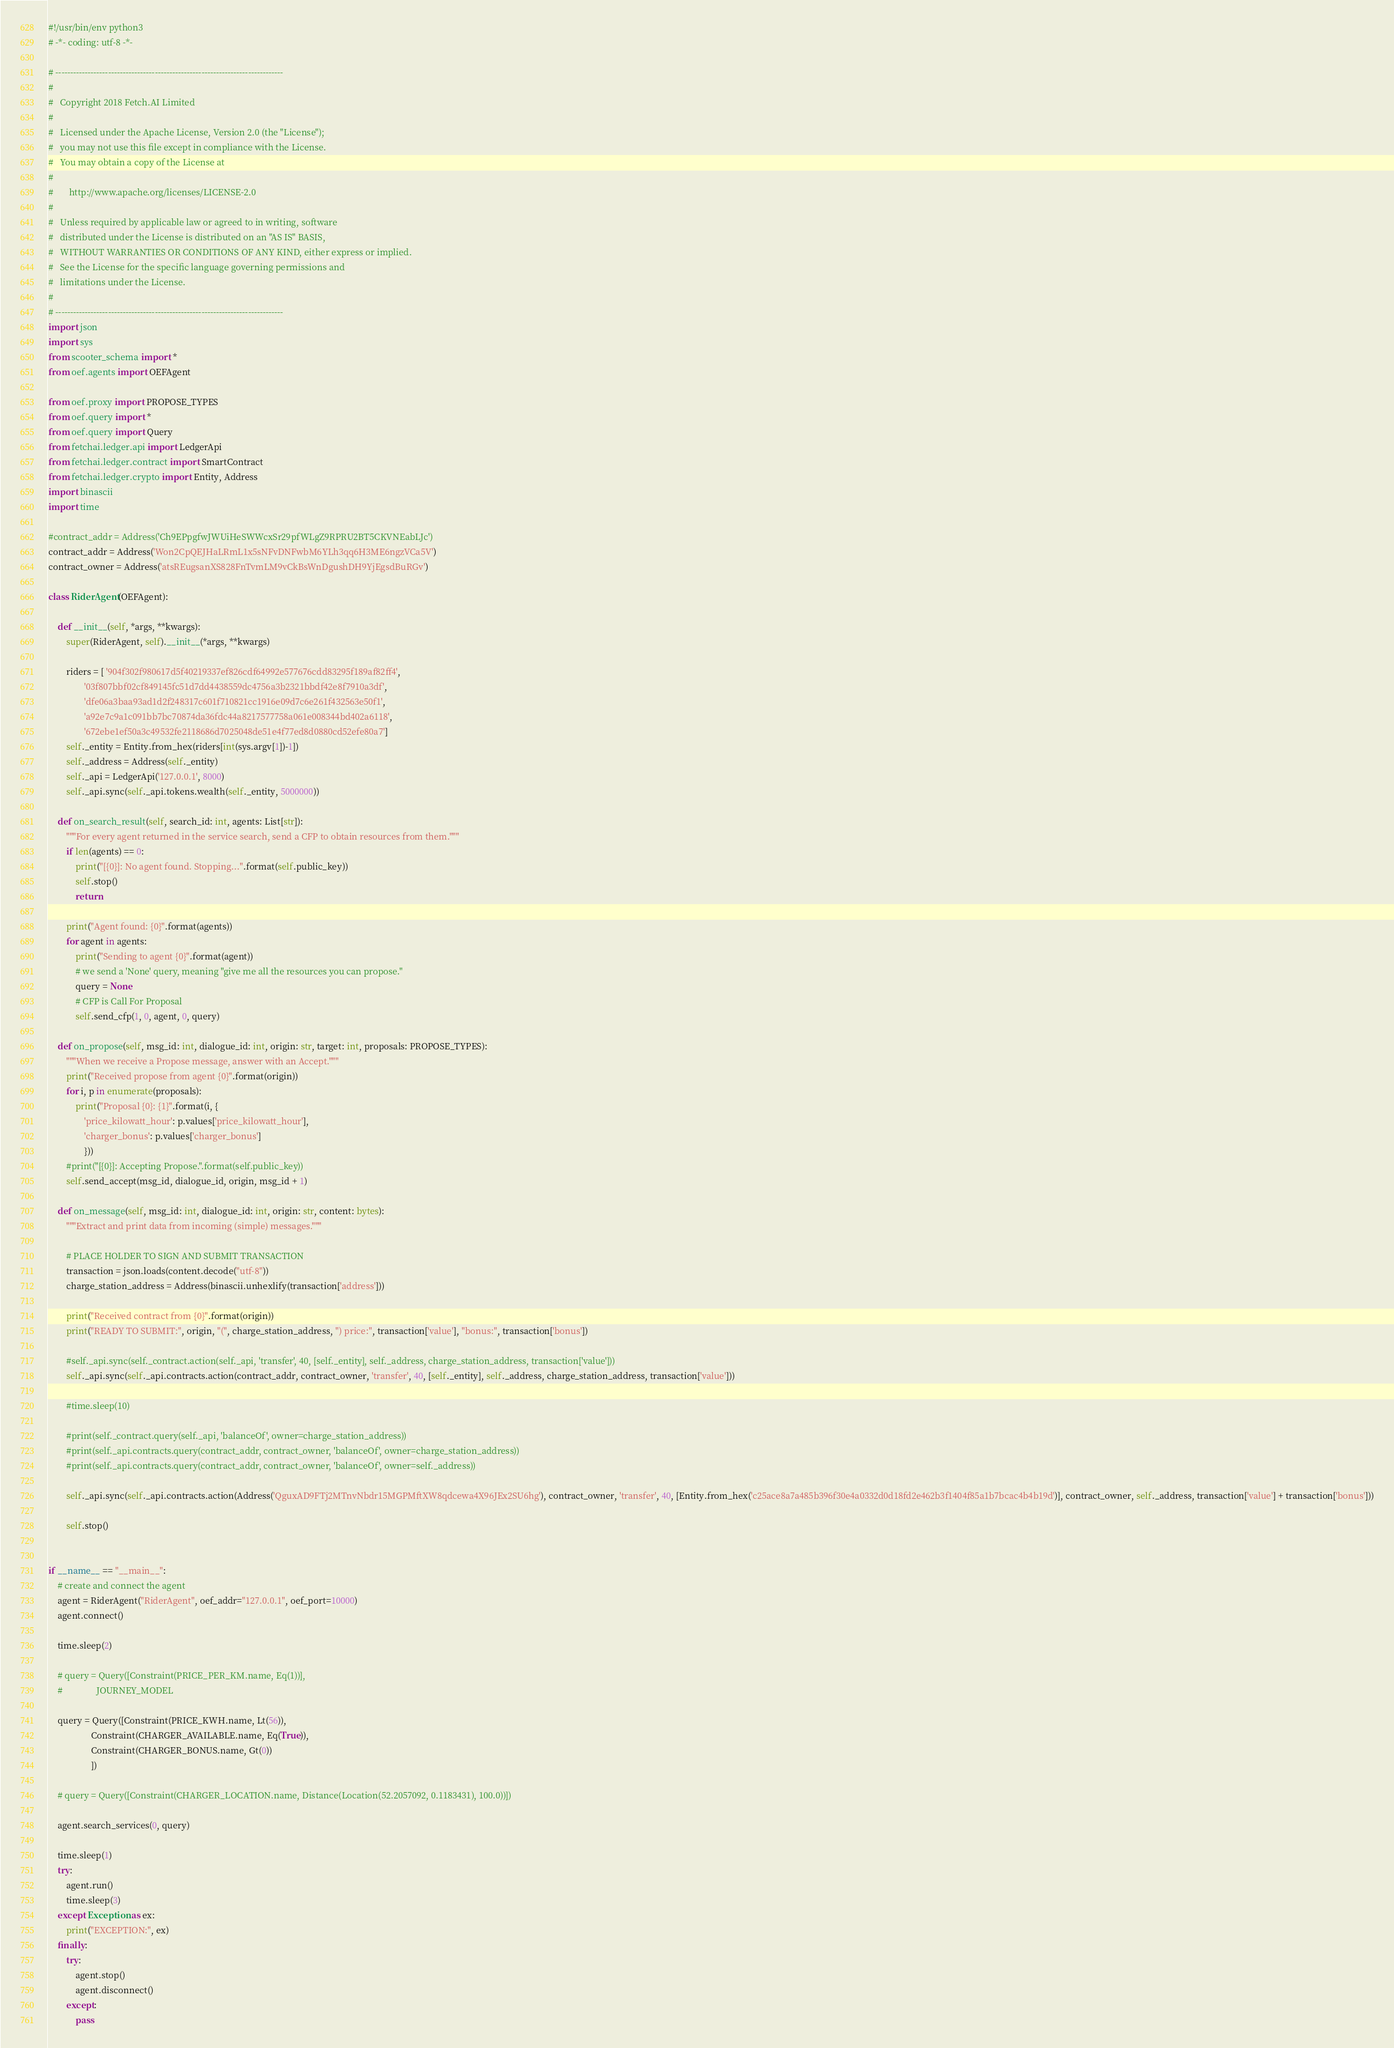<code> <loc_0><loc_0><loc_500><loc_500><_Python_>#!/usr/bin/env python3
# -*- coding: utf-8 -*-

# ------------------------------------------------------------------------------
#
#   Copyright 2018 Fetch.AI Limited
#
#   Licensed under the Apache License, Version 2.0 (the "License");
#   you may not use this file except in compliance with the License.
#   You may obtain a copy of the License at
#
#       http://www.apache.org/licenses/LICENSE-2.0
#
#   Unless required by applicable law or agreed to in writing, software
#   distributed under the License is distributed on an "AS IS" BASIS,
#   WITHOUT WARRANTIES OR CONDITIONS OF ANY KIND, either express or implied.
#   See the License for the specific language governing permissions and
#   limitations under the License.
#
# ------------------------------------------------------------------------------
import json
import sys
from scooter_schema import *
from oef.agents import OEFAgent

from oef.proxy import PROPOSE_TYPES
from oef.query import *
from oef.query import Query
from fetchai.ledger.api import LedgerApi
from fetchai.ledger.contract import SmartContract
from fetchai.ledger.crypto import Entity, Address
import binascii
import time

#contract_addr = Address('Ch9EPpgfwJWUiHeSWWcxSr29pfWLgZ9RPRU2BT5CKVNEabLJc')
contract_addr = Address('Won2CpQEJHaLRmL1x5sNFvDNFwbM6YLh3qq6H3ME6ngzVCa5V')
contract_owner = Address('atsREugsanXS828FnTvmLM9vCkBsWnDgushDH9YjEgsdBuRGv')

class RiderAgent(OEFAgent):

    def __init__(self, *args, **kwargs):
        super(RiderAgent, self).__init__(*args, **kwargs)

        riders = [ '904f302f980617d5f40219337ef826cdf64992e577676cdd83295f189af82ff4',
                '03f807bbf02cf849145fc51d7dd4438559dc4756a3b2321bbdf42e8f7910a3df',
                'dfe06a3baa93ad1d2f248317c601f710821cc1916e09d7c6e261f432563e50f1',
                'a92e7c9a1c091bb7bc70874da36fdc44a8217577758a061e008344bd402a6118',
                '672ebe1ef50a3c49532fe2118686d7025048de51e4f77ed8d0880cd52efe80a7']
        self._entity = Entity.from_hex(riders[int(sys.argv[1])-1])
        self._address = Address(self._entity)
        self._api = LedgerApi('127.0.0.1', 8000)
        self._api.sync(self._api.tokens.wealth(self._entity, 5000000))

    def on_search_result(self, search_id: int, agents: List[str]):
        """For every agent returned in the service search, send a CFP to obtain resources from them."""
        if len(agents) == 0:
            print("[{0}]: No agent found. Stopping...".format(self.public_key))
            self.stop()
            return

        print("Agent found: {0}".format(agents))
        for agent in agents:
            print("Sending to agent {0}".format(agent))
            # we send a 'None' query, meaning "give me all the resources you can propose."
            query = None
            # CFP is Call For Proposal
            self.send_cfp(1, 0, agent, 0, query)

    def on_propose(self, msg_id: int, dialogue_id: int, origin: str, target: int, proposals: PROPOSE_TYPES):
        """When we receive a Propose message, answer with an Accept."""
        print("Received propose from agent {0}".format(origin))
        for i, p in enumerate(proposals):
            print("Proposal {0}: {1}".format(i, {
                'price_kilowatt_hour': p.values['price_kilowatt_hour'],
                'charger_bonus': p.values['charger_bonus']
                }))
        #print("[{0}]: Accepting Propose.".format(self.public_key))
        self.send_accept(msg_id, dialogue_id, origin, msg_id + 1)

    def on_message(self, msg_id: int, dialogue_id: int, origin: str, content: bytes):
        """Extract and print data from incoming (simple) messages."""

        # PLACE HOLDER TO SIGN AND SUBMIT TRANSACTION
        transaction = json.loads(content.decode("utf-8"))
        charge_station_address = Address(binascii.unhexlify(transaction['address']))

        print("Received contract from {0}".format(origin))
        print("READY TO SUBMIT:", origin, "(", charge_station_address, ") price:", transaction['value'], "bonus:", transaction['bonus'])

        #self._api.sync(self._contract.action(self._api, 'transfer', 40, [self._entity], self._address, charge_station_address, transaction['value']))
        self._api.sync(self._api.contracts.action(contract_addr, contract_owner, 'transfer', 40, [self._entity], self._address, charge_station_address, transaction['value']))

        #time.sleep(10)

        #print(self._contract.query(self._api, 'balanceOf', owner=charge_station_address))
        #print(self._api.contracts.query(contract_addr, contract_owner, 'balanceOf', owner=charge_station_address))
        #print(self._api.contracts.query(contract_addr, contract_owner, 'balanceOf', owner=self._address))

        self._api.sync(self._api.contracts.action(Address('QguxAD9FTj2MTnvNbdr15MGPMftXW8qdcewa4X96JEx2SU6hg'), contract_owner, 'transfer', 40, [Entity.from_hex('c25ace8a7a485b396f30e4a0332d0d18fd2e462b3f1404f85a1b7bcac4b4b19d')], contract_owner, self._address, transaction['value'] + transaction['bonus']))

        self.stop()


if __name__ == "__main__":
    # create and connect the agent
    agent = RiderAgent("RiderAgent", oef_addr="127.0.0.1", oef_port=10000)
    agent.connect()

    time.sleep(2)

    # query = Query([Constraint(PRICE_PER_KM.name, Eq(1))],
    #               JOURNEY_MODEL

    query = Query([Constraint(PRICE_KWH.name, Lt(56)),
                   Constraint(CHARGER_AVAILABLE.name, Eq(True)),
                   Constraint(CHARGER_BONUS.name, Gt(0))
                   ])

    # query = Query([Constraint(CHARGER_LOCATION.name, Distance(Location(52.2057092, 0.1183431), 100.0))])

    agent.search_services(0, query)

    time.sleep(1)
    try:
        agent.run()
        time.sleep(3)
    except Exception as ex:
        print("EXCEPTION:", ex)
    finally:
        try:
            agent.stop()
            agent.disconnect()
        except:
            pass
</code> 